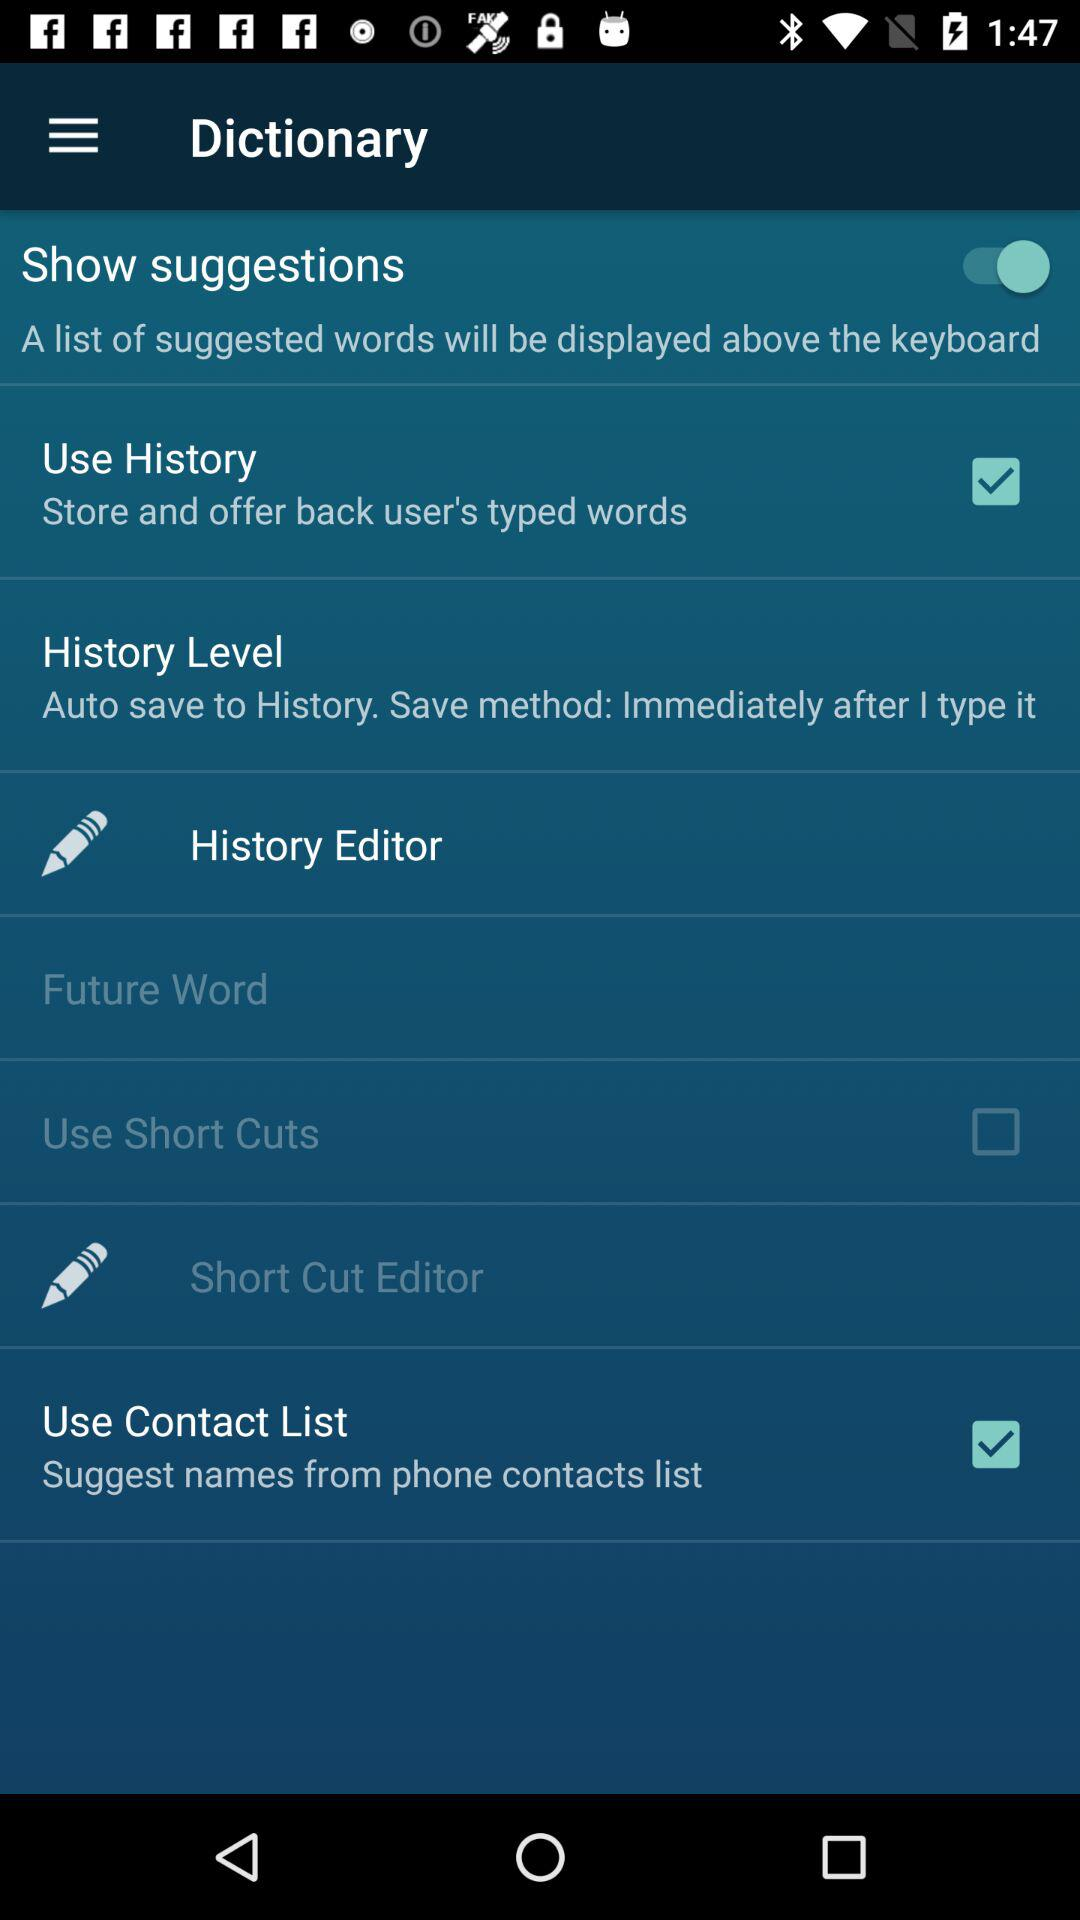What is the status of "Use Short Cuts"? The status is "off". 